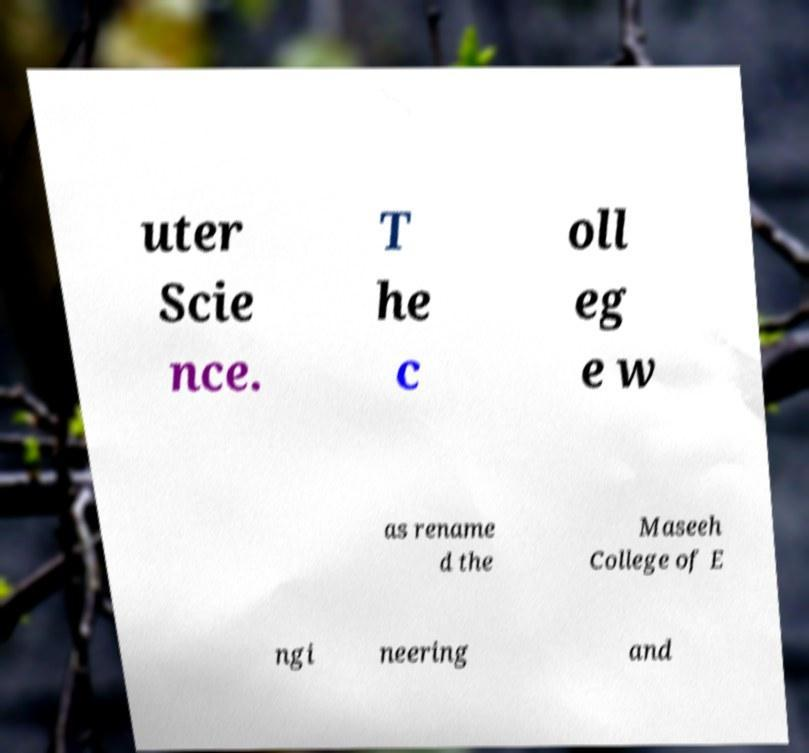Please identify and transcribe the text found in this image. uter Scie nce. T he c oll eg e w as rename d the Maseeh College of E ngi neering and 